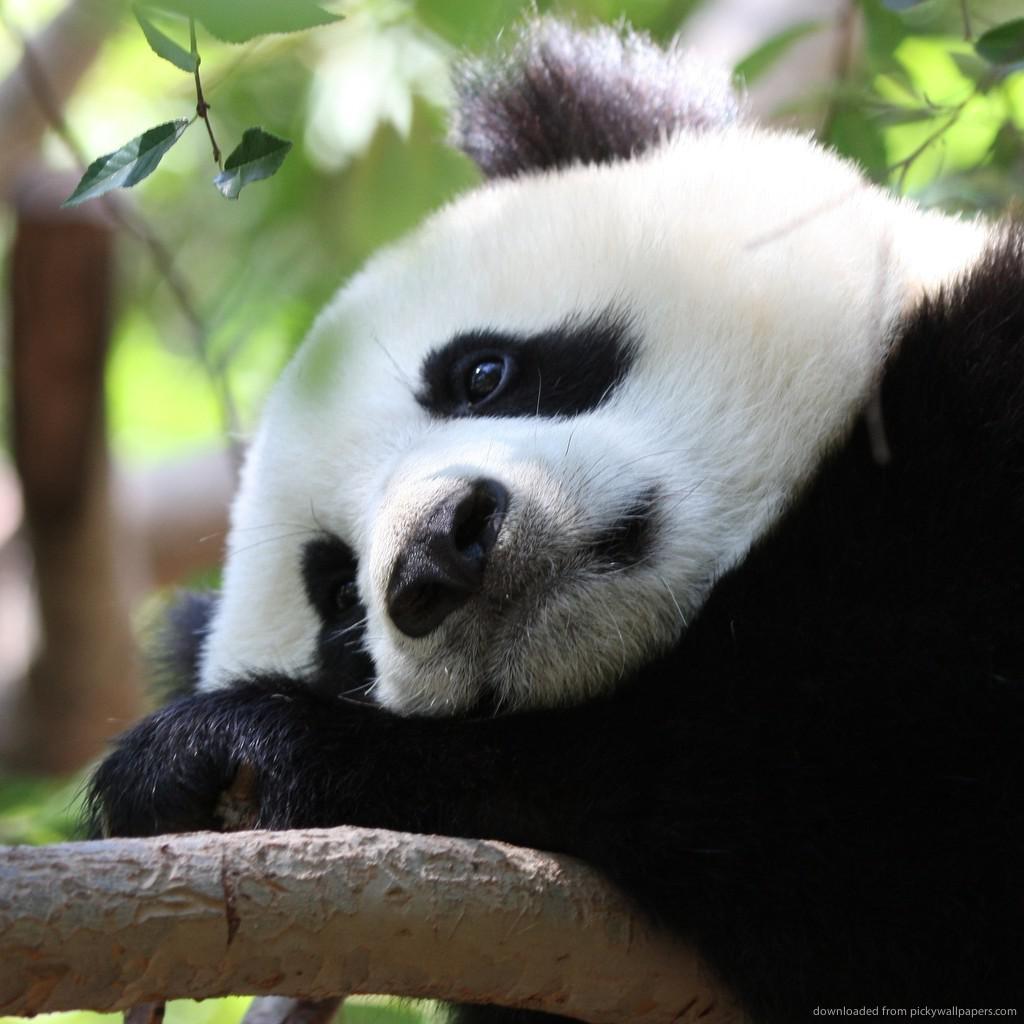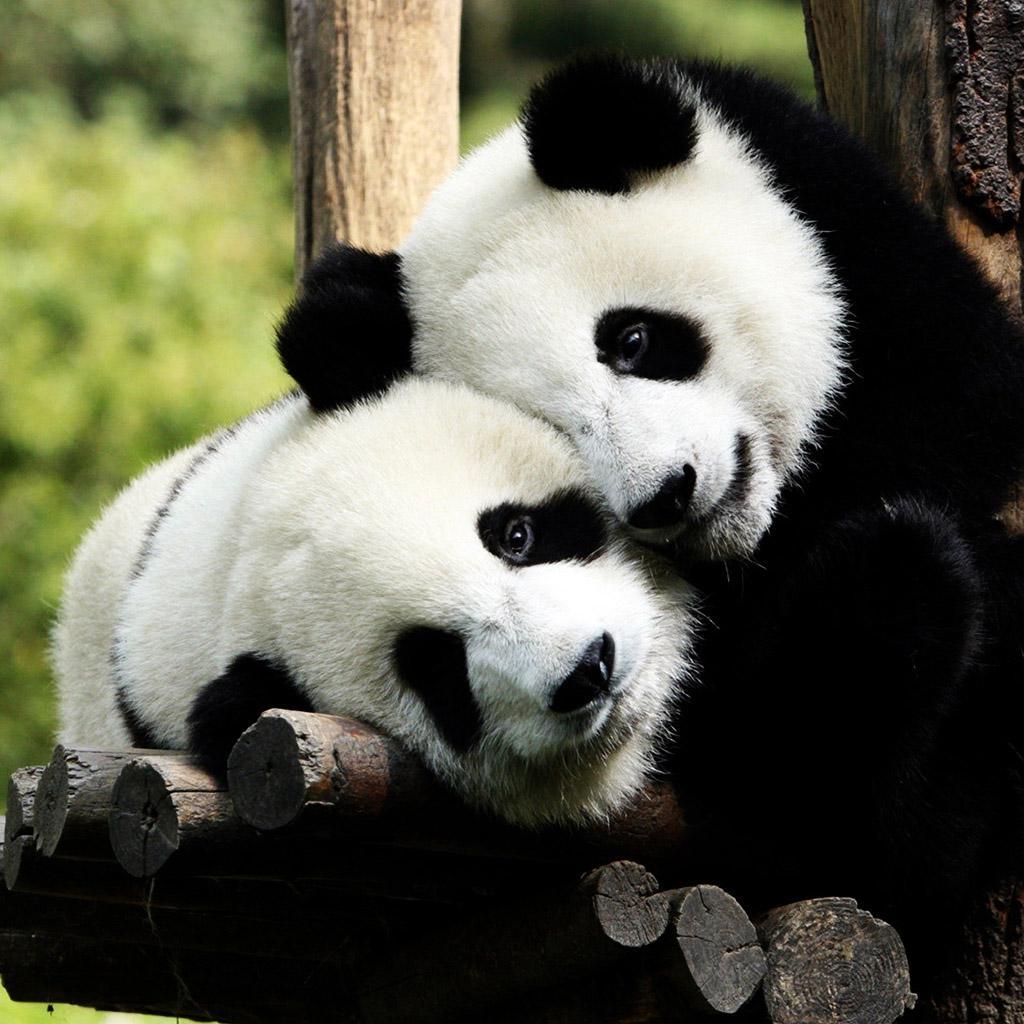The first image is the image on the left, the second image is the image on the right. Assess this claim about the two images: "At least one panda is playing with a bubble.". Correct or not? Answer yes or no. No. 